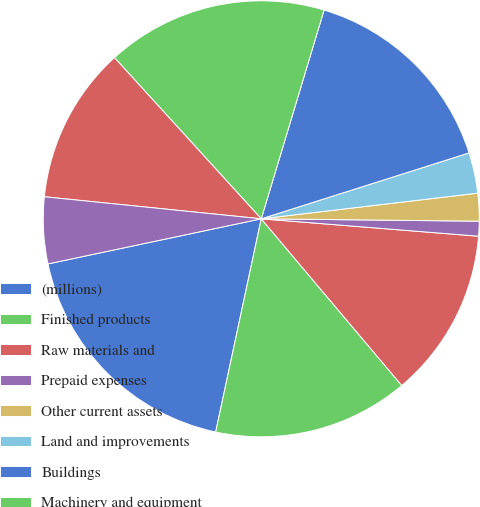Convert chart. <chart><loc_0><loc_0><loc_500><loc_500><pie_chart><fcel>(millions)<fcel>Finished products<fcel>Raw materials and<fcel>Prepaid expenses<fcel>Other current assets<fcel>Land and improvements<fcel>Buildings<fcel>Machinery and equipment<fcel>Software<fcel>Construction-in-progress<nl><fcel>18.33%<fcel>14.5%<fcel>12.58%<fcel>1.1%<fcel>2.05%<fcel>3.01%<fcel>15.46%<fcel>16.41%<fcel>11.63%<fcel>4.93%<nl></chart> 